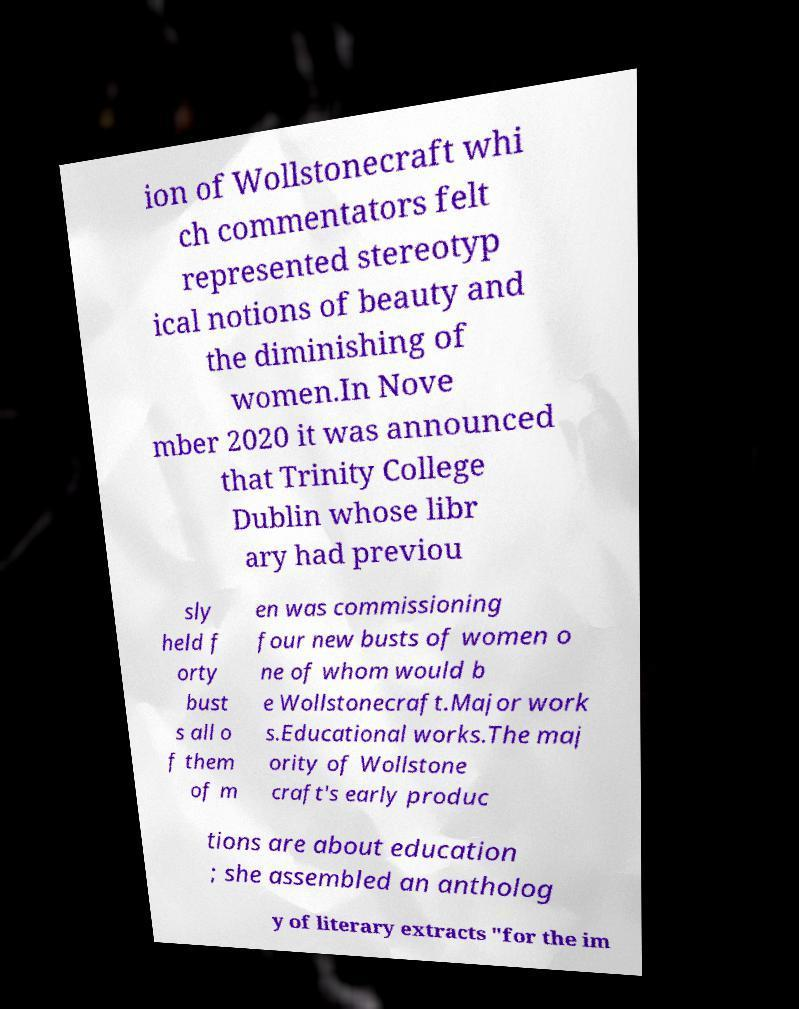Can you read and provide the text displayed in the image?This photo seems to have some interesting text. Can you extract and type it out for me? ion of Wollstonecraft whi ch commentators felt represented stereotyp ical notions of beauty and the diminishing of women.In Nove mber 2020 it was announced that Trinity College Dublin whose libr ary had previou sly held f orty bust s all o f them of m en was commissioning four new busts of women o ne of whom would b e Wollstonecraft.Major work s.Educational works.The maj ority of Wollstone craft's early produc tions are about education ; she assembled an antholog y of literary extracts "for the im 